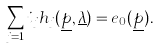Convert formula to latex. <formula><loc_0><loc_0><loc_500><loc_500>\sum _ { j = 1 } i _ { j } h _ { j } ( \underline { p } , \underline { \lambda } ) = e _ { 0 } ( \underline { p } ) .</formula> 